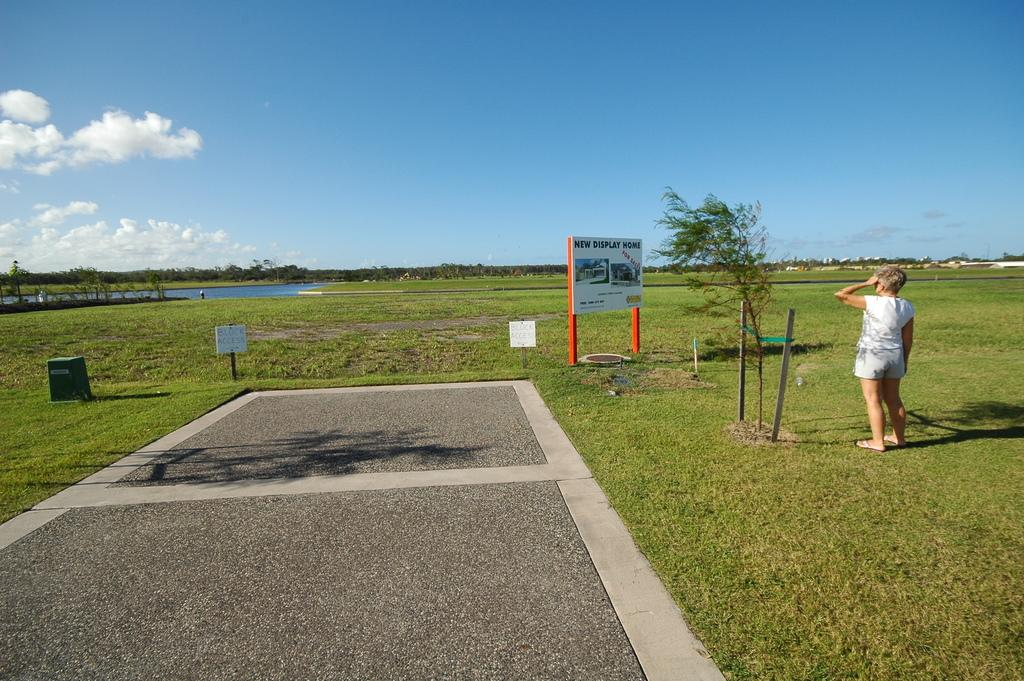What is the primary surface visible in the image? There is a ground in the image. What is placed on the ground? There is a board on the ground. What can be read on the board? There is text on the board. What other objects can be seen in the image? There are poles and plants in the image. What natural element is visible in the image? Water is visible in the image. Who is present in the image? There is a person in the image. What is visible at the top of the image? The sky is visible at the top of the image. What type of door can be seen in the image? There is no door present in the image. What is the nature of the argument between the two people in the image? There are no people arguing in the image, as there is only one person present. 